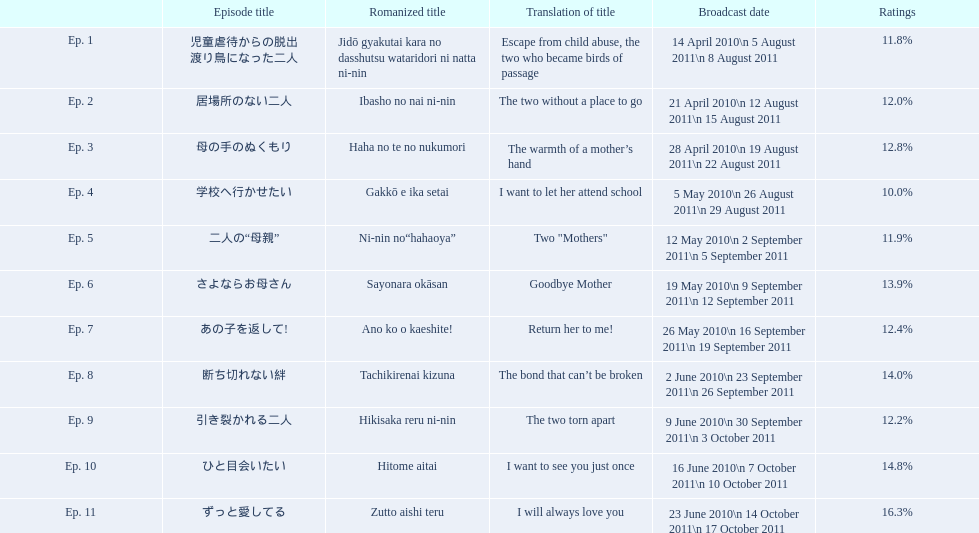What are the evaluation percentages for each episode? 11.8%, 12.0%, 12.8%, 10.0%, 11.9%, 13.9%, 12.4%, 14.0%, 12.2%, 14.8%, 16.3%. What is the maximum rating an episode achieved? 16.3%. What episode received a 16.3% rating? ずっと愛してる. 